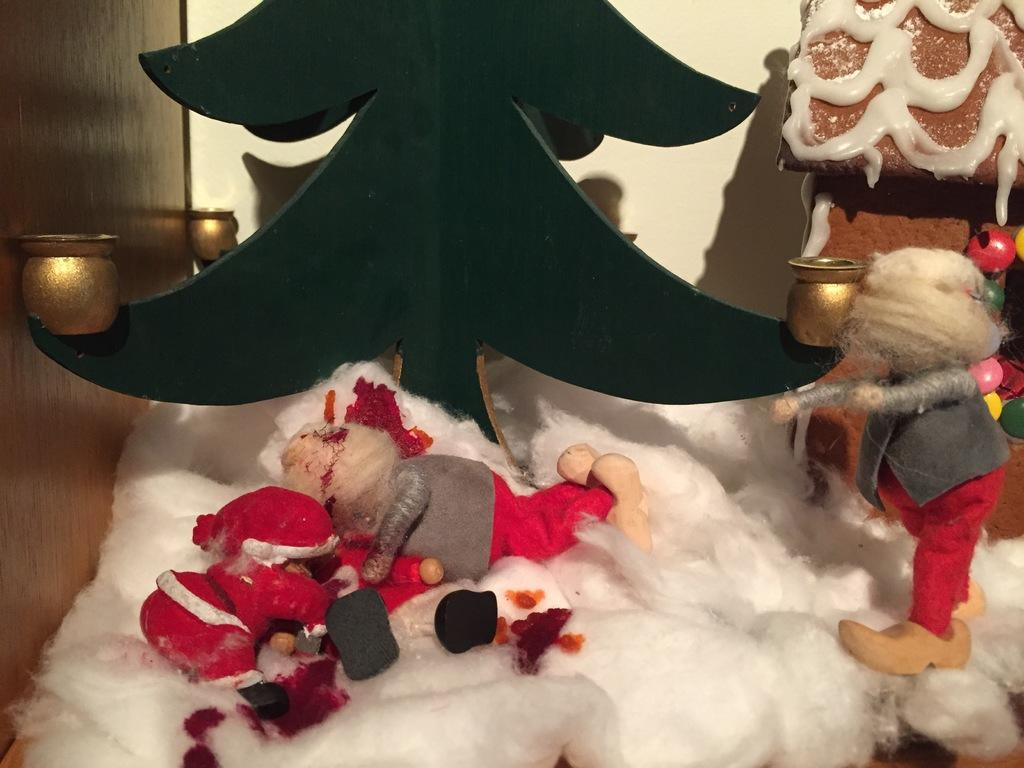What type of toy is in the image? There is a Christmas grandfather toy in the image. Where is the toy located in the image? The toy is on the left side of the image. What material is present in the middle of the image? There is cotton in the middle of the image. What type of meal is being prepared in the image? There is no meal preparation visible in the image; it features a Christmas grandfather toy and cotton. Can you tell me how many wrens are perched on the toy in the image? There are no wrens present in the image. 